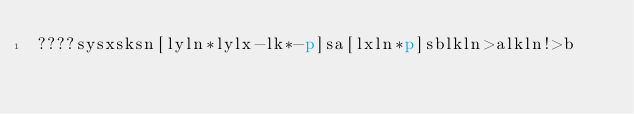Convert code to text. <code><loc_0><loc_0><loc_500><loc_500><_dc_>????sysxsksn[lyln*lylx-lk*-p]sa[lxln*p]sblkln>alkln!>b</code> 